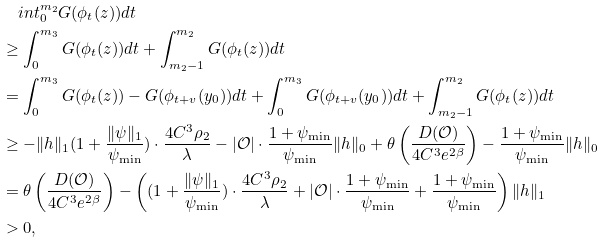Convert formula to latex. <formula><loc_0><loc_0><loc_500><loc_500>& \quad i n t _ { 0 } ^ { m _ { 2 } } G ( \phi _ { t } ( z ) ) d t \\ & \geq \int _ { 0 } ^ { m _ { 3 } } G ( \phi _ { t } ( z ) ) d t + \int _ { m _ { 2 } - 1 } ^ { m _ { 2 } } G ( \phi _ { t } ( z ) ) d t \\ & = \int _ { 0 } ^ { m _ { 3 } } G ( \phi _ { t } ( z ) ) - G ( \phi _ { t + v } ( y _ { 0 } ) ) d t + \int _ { 0 } ^ { m _ { 3 } } G ( \phi _ { t + v } ( y _ { 0 } ) ) d t + \int _ { m _ { 2 } - 1 } ^ { m _ { 2 } } G ( \phi _ { t } ( z ) ) d t \\ & \geq - \| h \| _ { 1 } ( 1 + \frac { \| \psi \| _ { 1 } } { \psi _ { \min } } ) \cdot \frac { 4 C ^ { 3 } \rho _ { 2 } } { \lambda } - | \mathcal { O } | \cdot \frac { 1 + \psi _ { \min } } { \psi _ { \min } } \| h \| _ { 0 } + \theta \left ( \frac { D ( \mathcal { O } ) } { 4 C ^ { 3 } e ^ { 2 \beta } } \right ) - \frac { 1 + \psi _ { \min } } { \psi _ { \min } } \| h \| _ { 0 } \\ & = \theta \left ( \frac { D ( \mathcal { O } ) } { 4 C ^ { 3 } e ^ { 2 \beta } } \right ) - \left ( ( 1 + \frac { \| \psi \| _ { 1 } } { \psi _ { \min } } ) \cdot \frac { 4 C ^ { 3 } \rho _ { 2 } } { \lambda } + | \mathcal { O } | \cdot \frac { 1 + \psi _ { \min } } { \psi _ { \min } } + \frac { 1 + \psi _ { \min } } { \psi _ { \min } } \right ) \| h \| _ { 1 } \\ & > 0 ,</formula> 